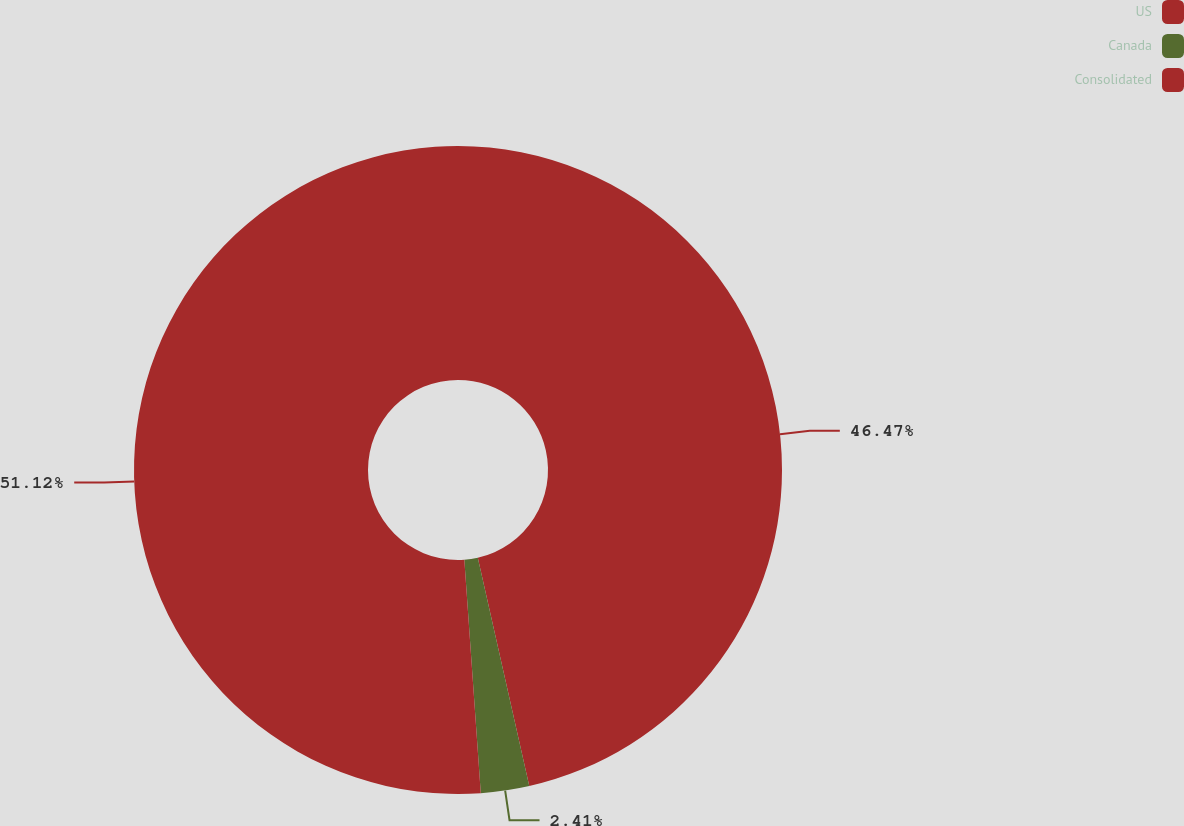Convert chart to OTSL. <chart><loc_0><loc_0><loc_500><loc_500><pie_chart><fcel>US<fcel>Canada<fcel>Consolidated<nl><fcel>46.47%<fcel>2.41%<fcel>51.12%<nl></chart> 